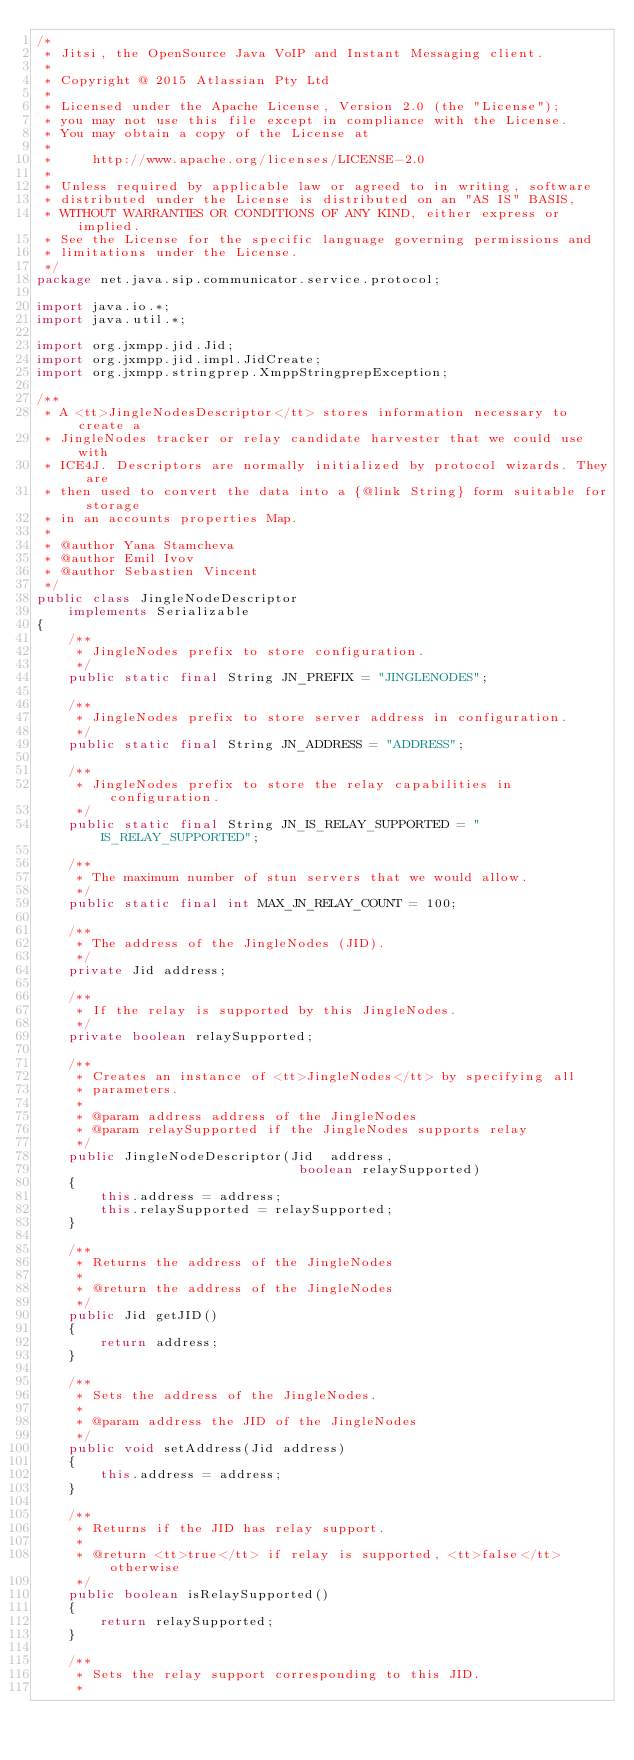<code> <loc_0><loc_0><loc_500><loc_500><_Java_>/*
 * Jitsi, the OpenSource Java VoIP and Instant Messaging client.
 *
 * Copyright @ 2015 Atlassian Pty Ltd
 *
 * Licensed under the Apache License, Version 2.0 (the "License");
 * you may not use this file except in compliance with the License.
 * You may obtain a copy of the License at
 *
 *     http://www.apache.org/licenses/LICENSE-2.0
 *
 * Unless required by applicable law or agreed to in writing, software
 * distributed under the License is distributed on an "AS IS" BASIS,
 * WITHOUT WARRANTIES OR CONDITIONS OF ANY KIND, either express or implied.
 * See the License for the specific language governing permissions and
 * limitations under the License.
 */
package net.java.sip.communicator.service.protocol;

import java.io.*;
import java.util.*;

import org.jxmpp.jid.Jid;
import org.jxmpp.jid.impl.JidCreate;
import org.jxmpp.stringprep.XmppStringprepException;

/**
 * A <tt>JingleNodesDescriptor</tt> stores information necessary to create a
 * JingleNodes tracker or relay candidate harvester that we could use with
 * ICE4J. Descriptors are normally initialized by protocol wizards. They are
 * then used to convert the data into a {@link String} form suitable for storage
 * in an accounts properties Map.
 *
 * @author Yana Stamcheva
 * @author Emil Ivov
 * @author Sebastien Vincent
 */
public class JingleNodeDescriptor
    implements Serializable
{
    /**
     * JingleNodes prefix to store configuration.
     */
    public static final String JN_PREFIX = "JINGLENODES";

    /**
     * JingleNodes prefix to store server address in configuration.
     */
    public static final String JN_ADDRESS = "ADDRESS";

    /**
     * JingleNodes prefix to store the relay capabilities in configuration.
     */
    public static final String JN_IS_RELAY_SUPPORTED = "IS_RELAY_SUPPORTED";

    /**
     * The maximum number of stun servers that we would allow.
     */
    public static final int MAX_JN_RELAY_COUNT = 100;

    /**
     * The address of the JingleNodes (JID).
     */
    private Jid address;

    /**
     * If the relay is supported by this JingleNodes.
     */
    private boolean relaySupported;

    /**
     * Creates an instance of <tt>JingleNodes</tt> by specifying all
     * parameters.
     *
     * @param address address of the JingleNodes
     * @param relaySupported if the JingleNodes supports relay
     */
    public JingleNodeDescriptor(Jid  address,
                                 boolean relaySupported)
    {
        this.address = address;
        this.relaySupported = relaySupported;
    }

    /**
     * Returns the address of the JingleNodes
     *
     * @return the address of the JingleNodes
     */
    public Jid getJID()
    {
        return address;
    }

    /**
     * Sets the address of the JingleNodes.
     *
     * @param address the JID of the JingleNodes
     */
    public void setAddress(Jid address)
    {
        this.address = address;
    }

    /**
     * Returns if the JID has relay support.
     *
     * @return <tt>true</tt> if relay is supported, <tt>false</tt> otherwise
     */
    public boolean isRelaySupported()
    {
        return relaySupported;
    }

    /**
     * Sets the relay support corresponding to this JID.
     *</code> 